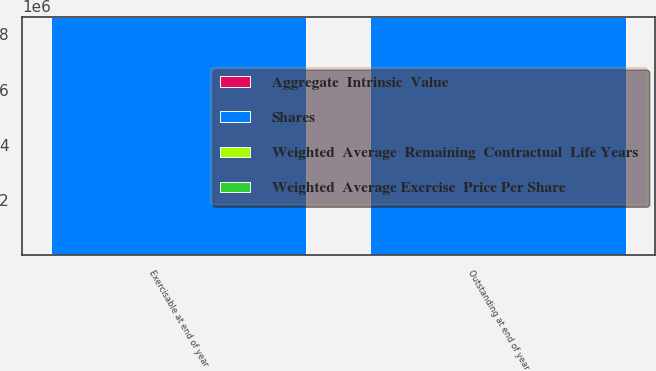Convert chart. <chart><loc_0><loc_0><loc_500><loc_500><stacked_bar_chart><ecel><fcel>Outstanding at end of year<fcel>Exercisable at end of year<nl><fcel>Shares<fcel>8.64661e+06<fcel>8.64039e+06<nl><fcel>Aggregate  Intrinsic  Value<fcel>72.64<fcel>72.6<nl><fcel>Weighted  Average Exercise  Price Per Share<fcel>4.67<fcel>4.67<nl><fcel>Weighted  Average  Remaining  Contractual  Life Years<fcel>718<fcel>718<nl></chart> 